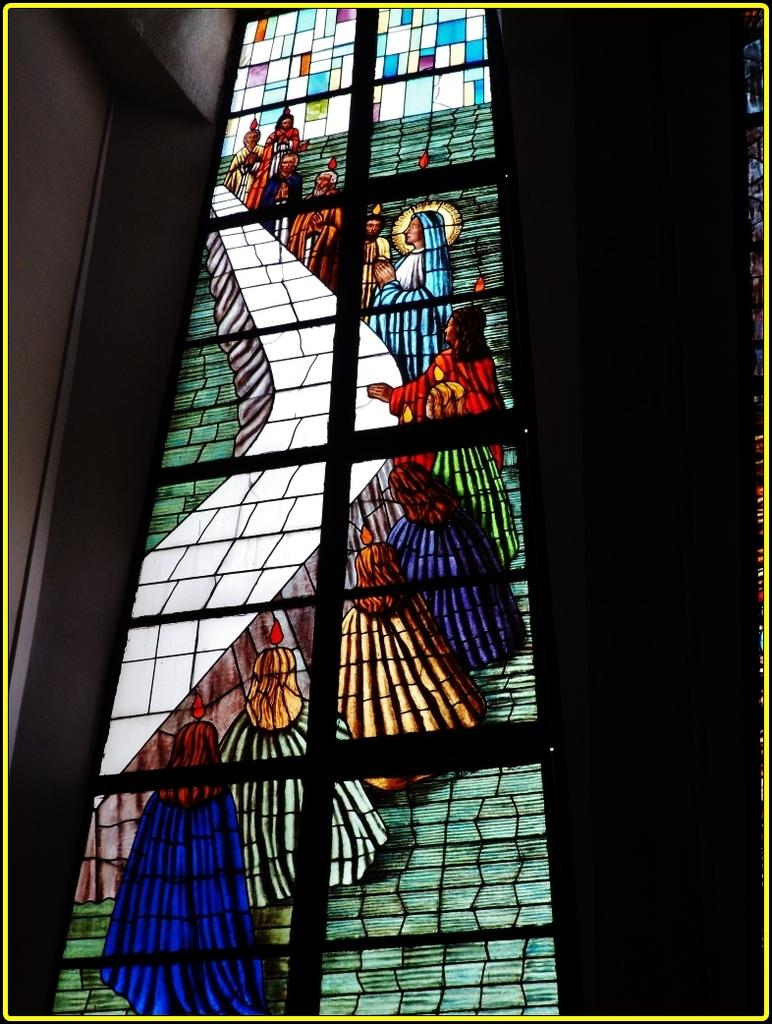What is the main subject of the image? The main subject of the image appears to be a glass. What is depicted on the glass? There is a painting done on the glass. What type of coil can be seen wrapped around the glass in the image? There is no coil present wrapped around the glass in the image. What is the source of the smoke coming from the glass in the image? There is no smoke coming from the glass in the image. 